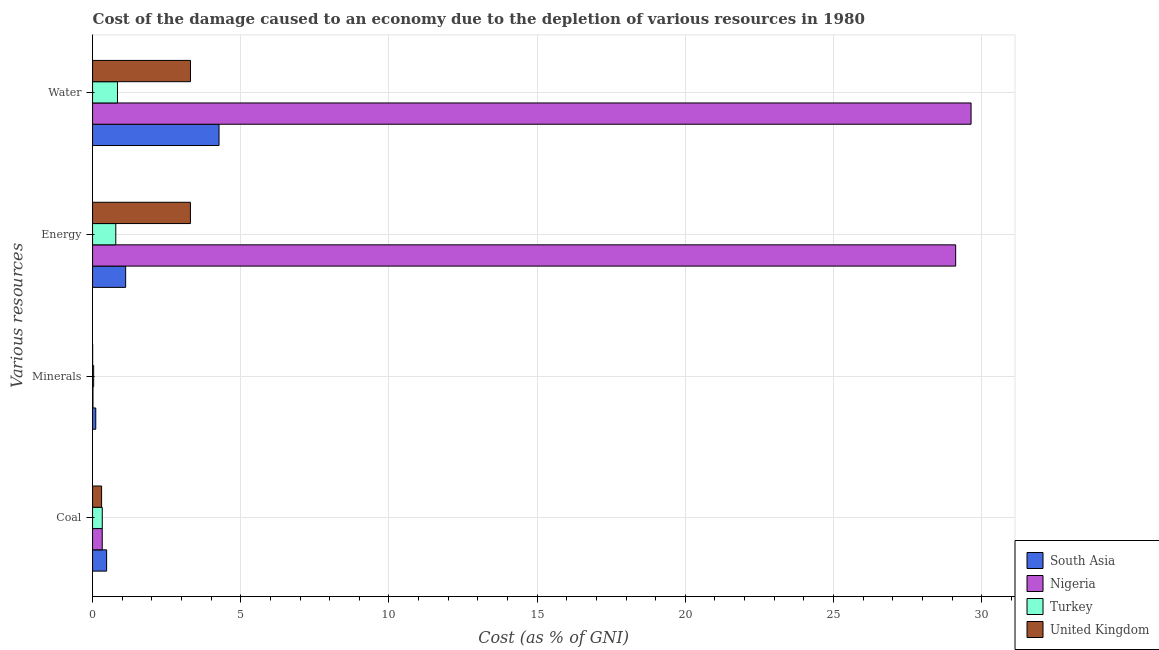How many different coloured bars are there?
Provide a succinct answer. 4. Are the number of bars per tick equal to the number of legend labels?
Make the answer very short. Yes. Are the number of bars on each tick of the Y-axis equal?
Ensure brevity in your answer.  Yes. How many bars are there on the 1st tick from the top?
Ensure brevity in your answer.  4. What is the label of the 3rd group of bars from the top?
Your answer should be very brief. Minerals. What is the cost of damage due to depletion of water in Nigeria?
Your answer should be compact. 29.64. Across all countries, what is the maximum cost of damage due to depletion of minerals?
Your answer should be very brief. 0.11. Across all countries, what is the minimum cost of damage due to depletion of energy?
Keep it short and to the point. 0.78. In which country was the cost of damage due to depletion of water minimum?
Your answer should be very brief. Turkey. What is the total cost of damage due to depletion of coal in the graph?
Provide a succinct answer. 1.43. What is the difference between the cost of damage due to depletion of water in Turkey and that in Nigeria?
Your response must be concise. -28.8. What is the difference between the cost of damage due to depletion of minerals in Turkey and the cost of damage due to depletion of water in United Kingdom?
Provide a succinct answer. -3.27. What is the average cost of damage due to depletion of water per country?
Your response must be concise. 9.51. What is the difference between the cost of damage due to depletion of coal and cost of damage due to depletion of minerals in United Kingdom?
Your answer should be compact. 0.3. What is the ratio of the cost of damage due to depletion of water in United Kingdom to that in Turkey?
Offer a terse response. 3.93. Is the difference between the cost of damage due to depletion of water in Turkey and Nigeria greater than the difference between the cost of damage due to depletion of coal in Turkey and Nigeria?
Give a very brief answer. No. What is the difference between the highest and the second highest cost of damage due to depletion of energy?
Your answer should be very brief. 25.82. What is the difference between the highest and the lowest cost of damage due to depletion of energy?
Provide a succinct answer. 28.34. In how many countries, is the cost of damage due to depletion of energy greater than the average cost of damage due to depletion of energy taken over all countries?
Your answer should be compact. 1. Is the sum of the cost of damage due to depletion of water in Turkey and United Kingdom greater than the maximum cost of damage due to depletion of minerals across all countries?
Your answer should be very brief. Yes. Is it the case that in every country, the sum of the cost of damage due to depletion of water and cost of damage due to depletion of minerals is greater than the sum of cost of damage due to depletion of coal and cost of damage due to depletion of energy?
Ensure brevity in your answer.  Yes. What does the 3rd bar from the bottom in Minerals represents?
Provide a short and direct response. Turkey. How many bars are there?
Your answer should be very brief. 16. What is the difference between two consecutive major ticks on the X-axis?
Make the answer very short. 5. Are the values on the major ticks of X-axis written in scientific E-notation?
Your answer should be very brief. No. Does the graph contain any zero values?
Offer a terse response. No. Does the graph contain grids?
Offer a terse response. Yes. How many legend labels are there?
Provide a short and direct response. 4. How are the legend labels stacked?
Make the answer very short. Vertical. What is the title of the graph?
Your response must be concise. Cost of the damage caused to an economy due to the depletion of various resources in 1980 . Does "United States" appear as one of the legend labels in the graph?
Make the answer very short. No. What is the label or title of the X-axis?
Provide a short and direct response. Cost (as % of GNI). What is the label or title of the Y-axis?
Offer a very short reply. Various resources. What is the Cost (as % of GNI) of South Asia in Coal?
Offer a very short reply. 0.47. What is the Cost (as % of GNI) in Nigeria in Coal?
Your response must be concise. 0.33. What is the Cost (as % of GNI) of Turkey in Coal?
Your response must be concise. 0.33. What is the Cost (as % of GNI) in United Kingdom in Coal?
Give a very brief answer. 0.3. What is the Cost (as % of GNI) of South Asia in Minerals?
Give a very brief answer. 0.11. What is the Cost (as % of GNI) in Nigeria in Minerals?
Your answer should be compact. 0.01. What is the Cost (as % of GNI) in Turkey in Minerals?
Ensure brevity in your answer.  0.04. What is the Cost (as % of GNI) in United Kingdom in Minerals?
Keep it short and to the point. 0. What is the Cost (as % of GNI) in South Asia in Energy?
Provide a short and direct response. 1.12. What is the Cost (as % of GNI) of Nigeria in Energy?
Offer a very short reply. 29.12. What is the Cost (as % of GNI) in Turkey in Energy?
Ensure brevity in your answer.  0.78. What is the Cost (as % of GNI) of United Kingdom in Energy?
Give a very brief answer. 3.3. What is the Cost (as % of GNI) of South Asia in Water?
Your response must be concise. 4.27. What is the Cost (as % of GNI) in Nigeria in Water?
Offer a very short reply. 29.64. What is the Cost (as % of GNI) of Turkey in Water?
Your answer should be very brief. 0.84. What is the Cost (as % of GNI) in United Kingdom in Water?
Offer a very short reply. 3.3. Across all Various resources, what is the maximum Cost (as % of GNI) in South Asia?
Offer a terse response. 4.27. Across all Various resources, what is the maximum Cost (as % of GNI) in Nigeria?
Provide a short and direct response. 29.64. Across all Various resources, what is the maximum Cost (as % of GNI) in Turkey?
Your response must be concise. 0.84. Across all Various resources, what is the maximum Cost (as % of GNI) of United Kingdom?
Offer a very short reply. 3.3. Across all Various resources, what is the minimum Cost (as % of GNI) of South Asia?
Your answer should be compact. 0.11. Across all Various resources, what is the minimum Cost (as % of GNI) of Nigeria?
Ensure brevity in your answer.  0.01. Across all Various resources, what is the minimum Cost (as % of GNI) of Turkey?
Provide a succinct answer. 0.04. Across all Various resources, what is the minimum Cost (as % of GNI) in United Kingdom?
Your answer should be compact. 0. What is the total Cost (as % of GNI) in South Asia in the graph?
Your response must be concise. 5.96. What is the total Cost (as % of GNI) of Nigeria in the graph?
Ensure brevity in your answer.  59.11. What is the total Cost (as % of GNI) of Turkey in the graph?
Ensure brevity in your answer.  1.99. What is the total Cost (as % of GNI) of United Kingdom in the graph?
Offer a terse response. 6.91. What is the difference between the Cost (as % of GNI) of South Asia in Coal and that in Minerals?
Provide a short and direct response. 0.37. What is the difference between the Cost (as % of GNI) of Nigeria in Coal and that in Minerals?
Offer a terse response. 0.31. What is the difference between the Cost (as % of GNI) in Turkey in Coal and that in Minerals?
Ensure brevity in your answer.  0.29. What is the difference between the Cost (as % of GNI) of United Kingdom in Coal and that in Minerals?
Provide a succinct answer. 0.3. What is the difference between the Cost (as % of GNI) in South Asia in Coal and that in Energy?
Make the answer very short. -0.64. What is the difference between the Cost (as % of GNI) in Nigeria in Coal and that in Energy?
Your answer should be very brief. -28.8. What is the difference between the Cost (as % of GNI) of Turkey in Coal and that in Energy?
Provide a succinct answer. -0.46. What is the difference between the Cost (as % of GNI) of United Kingdom in Coal and that in Energy?
Your answer should be compact. -3. What is the difference between the Cost (as % of GNI) in South Asia in Coal and that in Water?
Keep it short and to the point. -3.79. What is the difference between the Cost (as % of GNI) in Nigeria in Coal and that in Water?
Your answer should be compact. -29.32. What is the difference between the Cost (as % of GNI) in Turkey in Coal and that in Water?
Make the answer very short. -0.51. What is the difference between the Cost (as % of GNI) of United Kingdom in Coal and that in Water?
Your answer should be very brief. -3. What is the difference between the Cost (as % of GNI) in South Asia in Minerals and that in Energy?
Your response must be concise. -1.01. What is the difference between the Cost (as % of GNI) of Nigeria in Minerals and that in Energy?
Ensure brevity in your answer.  -29.11. What is the difference between the Cost (as % of GNI) in Turkey in Minerals and that in Energy?
Ensure brevity in your answer.  -0.75. What is the difference between the Cost (as % of GNI) of United Kingdom in Minerals and that in Energy?
Ensure brevity in your answer.  -3.3. What is the difference between the Cost (as % of GNI) in South Asia in Minerals and that in Water?
Offer a terse response. -4.16. What is the difference between the Cost (as % of GNI) of Nigeria in Minerals and that in Water?
Offer a very short reply. -29.63. What is the difference between the Cost (as % of GNI) in Turkey in Minerals and that in Water?
Ensure brevity in your answer.  -0.8. What is the difference between the Cost (as % of GNI) of United Kingdom in Minerals and that in Water?
Ensure brevity in your answer.  -3.3. What is the difference between the Cost (as % of GNI) of South Asia in Energy and that in Water?
Make the answer very short. -3.15. What is the difference between the Cost (as % of GNI) of Nigeria in Energy and that in Water?
Ensure brevity in your answer.  -0.52. What is the difference between the Cost (as % of GNI) of Turkey in Energy and that in Water?
Provide a short and direct response. -0.06. What is the difference between the Cost (as % of GNI) of United Kingdom in Energy and that in Water?
Offer a very short reply. -0. What is the difference between the Cost (as % of GNI) in South Asia in Coal and the Cost (as % of GNI) in Nigeria in Minerals?
Offer a very short reply. 0.46. What is the difference between the Cost (as % of GNI) of South Asia in Coal and the Cost (as % of GNI) of Turkey in Minerals?
Ensure brevity in your answer.  0.44. What is the difference between the Cost (as % of GNI) in South Asia in Coal and the Cost (as % of GNI) in United Kingdom in Minerals?
Give a very brief answer. 0.47. What is the difference between the Cost (as % of GNI) in Nigeria in Coal and the Cost (as % of GNI) in Turkey in Minerals?
Provide a succinct answer. 0.29. What is the difference between the Cost (as % of GNI) of Nigeria in Coal and the Cost (as % of GNI) of United Kingdom in Minerals?
Give a very brief answer. 0.32. What is the difference between the Cost (as % of GNI) of Turkey in Coal and the Cost (as % of GNI) of United Kingdom in Minerals?
Your answer should be compact. 0.32. What is the difference between the Cost (as % of GNI) in South Asia in Coal and the Cost (as % of GNI) in Nigeria in Energy?
Your response must be concise. -28.65. What is the difference between the Cost (as % of GNI) in South Asia in Coal and the Cost (as % of GNI) in Turkey in Energy?
Keep it short and to the point. -0.31. What is the difference between the Cost (as % of GNI) of South Asia in Coal and the Cost (as % of GNI) of United Kingdom in Energy?
Provide a succinct answer. -2.83. What is the difference between the Cost (as % of GNI) of Nigeria in Coal and the Cost (as % of GNI) of Turkey in Energy?
Offer a terse response. -0.46. What is the difference between the Cost (as % of GNI) of Nigeria in Coal and the Cost (as % of GNI) of United Kingdom in Energy?
Your response must be concise. -2.98. What is the difference between the Cost (as % of GNI) in Turkey in Coal and the Cost (as % of GNI) in United Kingdom in Energy?
Ensure brevity in your answer.  -2.97. What is the difference between the Cost (as % of GNI) of South Asia in Coal and the Cost (as % of GNI) of Nigeria in Water?
Your answer should be compact. -29.17. What is the difference between the Cost (as % of GNI) of South Asia in Coal and the Cost (as % of GNI) of Turkey in Water?
Provide a short and direct response. -0.37. What is the difference between the Cost (as % of GNI) in South Asia in Coal and the Cost (as % of GNI) in United Kingdom in Water?
Provide a short and direct response. -2.83. What is the difference between the Cost (as % of GNI) of Nigeria in Coal and the Cost (as % of GNI) of Turkey in Water?
Ensure brevity in your answer.  -0.52. What is the difference between the Cost (as % of GNI) of Nigeria in Coal and the Cost (as % of GNI) of United Kingdom in Water?
Make the answer very short. -2.98. What is the difference between the Cost (as % of GNI) in Turkey in Coal and the Cost (as % of GNI) in United Kingdom in Water?
Your answer should be compact. -2.98. What is the difference between the Cost (as % of GNI) of South Asia in Minerals and the Cost (as % of GNI) of Nigeria in Energy?
Offer a very short reply. -29.02. What is the difference between the Cost (as % of GNI) of South Asia in Minerals and the Cost (as % of GNI) of Turkey in Energy?
Offer a terse response. -0.68. What is the difference between the Cost (as % of GNI) in South Asia in Minerals and the Cost (as % of GNI) in United Kingdom in Energy?
Provide a succinct answer. -3.19. What is the difference between the Cost (as % of GNI) of Nigeria in Minerals and the Cost (as % of GNI) of Turkey in Energy?
Your answer should be compact. -0.77. What is the difference between the Cost (as % of GNI) of Nigeria in Minerals and the Cost (as % of GNI) of United Kingdom in Energy?
Make the answer very short. -3.29. What is the difference between the Cost (as % of GNI) in Turkey in Minerals and the Cost (as % of GNI) in United Kingdom in Energy?
Ensure brevity in your answer.  -3.27. What is the difference between the Cost (as % of GNI) of South Asia in Minerals and the Cost (as % of GNI) of Nigeria in Water?
Your answer should be very brief. -29.54. What is the difference between the Cost (as % of GNI) of South Asia in Minerals and the Cost (as % of GNI) of Turkey in Water?
Your answer should be very brief. -0.73. What is the difference between the Cost (as % of GNI) of South Asia in Minerals and the Cost (as % of GNI) of United Kingdom in Water?
Keep it short and to the point. -3.2. What is the difference between the Cost (as % of GNI) in Nigeria in Minerals and the Cost (as % of GNI) in Turkey in Water?
Your answer should be compact. -0.83. What is the difference between the Cost (as % of GNI) of Nigeria in Minerals and the Cost (as % of GNI) of United Kingdom in Water?
Your answer should be very brief. -3.29. What is the difference between the Cost (as % of GNI) of Turkey in Minerals and the Cost (as % of GNI) of United Kingdom in Water?
Your answer should be very brief. -3.27. What is the difference between the Cost (as % of GNI) in South Asia in Energy and the Cost (as % of GNI) in Nigeria in Water?
Your answer should be compact. -28.53. What is the difference between the Cost (as % of GNI) of South Asia in Energy and the Cost (as % of GNI) of Turkey in Water?
Make the answer very short. 0.28. What is the difference between the Cost (as % of GNI) in South Asia in Energy and the Cost (as % of GNI) in United Kingdom in Water?
Offer a very short reply. -2.19. What is the difference between the Cost (as % of GNI) in Nigeria in Energy and the Cost (as % of GNI) in Turkey in Water?
Keep it short and to the point. 28.28. What is the difference between the Cost (as % of GNI) in Nigeria in Energy and the Cost (as % of GNI) in United Kingdom in Water?
Ensure brevity in your answer.  25.82. What is the difference between the Cost (as % of GNI) of Turkey in Energy and the Cost (as % of GNI) of United Kingdom in Water?
Provide a succinct answer. -2.52. What is the average Cost (as % of GNI) of South Asia per Various resources?
Your answer should be compact. 1.49. What is the average Cost (as % of GNI) in Nigeria per Various resources?
Your answer should be very brief. 14.78. What is the average Cost (as % of GNI) of Turkey per Various resources?
Your answer should be very brief. 0.5. What is the average Cost (as % of GNI) in United Kingdom per Various resources?
Your answer should be compact. 1.73. What is the difference between the Cost (as % of GNI) in South Asia and Cost (as % of GNI) in Nigeria in Coal?
Provide a succinct answer. 0.15. What is the difference between the Cost (as % of GNI) in South Asia and Cost (as % of GNI) in Turkey in Coal?
Give a very brief answer. 0.15. What is the difference between the Cost (as % of GNI) in South Asia and Cost (as % of GNI) in United Kingdom in Coal?
Your answer should be very brief. 0.17. What is the difference between the Cost (as % of GNI) in Nigeria and Cost (as % of GNI) in Turkey in Coal?
Offer a terse response. -0. What is the difference between the Cost (as % of GNI) in Nigeria and Cost (as % of GNI) in United Kingdom in Coal?
Make the answer very short. 0.02. What is the difference between the Cost (as % of GNI) of Turkey and Cost (as % of GNI) of United Kingdom in Coal?
Keep it short and to the point. 0.02. What is the difference between the Cost (as % of GNI) in South Asia and Cost (as % of GNI) in Nigeria in Minerals?
Your answer should be compact. 0.09. What is the difference between the Cost (as % of GNI) of South Asia and Cost (as % of GNI) of Turkey in Minerals?
Your answer should be very brief. 0.07. What is the difference between the Cost (as % of GNI) in South Asia and Cost (as % of GNI) in United Kingdom in Minerals?
Your answer should be very brief. 0.11. What is the difference between the Cost (as % of GNI) in Nigeria and Cost (as % of GNI) in Turkey in Minerals?
Provide a succinct answer. -0.02. What is the difference between the Cost (as % of GNI) of Nigeria and Cost (as % of GNI) of United Kingdom in Minerals?
Make the answer very short. 0.01. What is the difference between the Cost (as % of GNI) of Turkey and Cost (as % of GNI) of United Kingdom in Minerals?
Your answer should be compact. 0.03. What is the difference between the Cost (as % of GNI) of South Asia and Cost (as % of GNI) of Nigeria in Energy?
Your answer should be compact. -28.01. What is the difference between the Cost (as % of GNI) in South Asia and Cost (as % of GNI) in Turkey in Energy?
Make the answer very short. 0.33. What is the difference between the Cost (as % of GNI) of South Asia and Cost (as % of GNI) of United Kingdom in Energy?
Make the answer very short. -2.19. What is the difference between the Cost (as % of GNI) in Nigeria and Cost (as % of GNI) in Turkey in Energy?
Make the answer very short. 28.34. What is the difference between the Cost (as % of GNI) of Nigeria and Cost (as % of GNI) of United Kingdom in Energy?
Your answer should be compact. 25.82. What is the difference between the Cost (as % of GNI) of Turkey and Cost (as % of GNI) of United Kingdom in Energy?
Provide a short and direct response. -2.52. What is the difference between the Cost (as % of GNI) of South Asia and Cost (as % of GNI) of Nigeria in Water?
Make the answer very short. -25.38. What is the difference between the Cost (as % of GNI) of South Asia and Cost (as % of GNI) of Turkey in Water?
Make the answer very short. 3.43. What is the difference between the Cost (as % of GNI) in South Asia and Cost (as % of GNI) in United Kingdom in Water?
Your response must be concise. 0.96. What is the difference between the Cost (as % of GNI) in Nigeria and Cost (as % of GNI) in Turkey in Water?
Your answer should be very brief. 28.8. What is the difference between the Cost (as % of GNI) of Nigeria and Cost (as % of GNI) of United Kingdom in Water?
Offer a terse response. 26.34. What is the difference between the Cost (as % of GNI) in Turkey and Cost (as % of GNI) in United Kingdom in Water?
Provide a short and direct response. -2.46. What is the ratio of the Cost (as % of GNI) of South Asia in Coal to that in Minerals?
Your answer should be compact. 4.4. What is the ratio of the Cost (as % of GNI) of Nigeria in Coal to that in Minerals?
Your response must be concise. 23.45. What is the ratio of the Cost (as % of GNI) of Turkey in Coal to that in Minerals?
Keep it short and to the point. 8.94. What is the ratio of the Cost (as % of GNI) of United Kingdom in Coal to that in Minerals?
Your response must be concise. 120.98. What is the ratio of the Cost (as % of GNI) in South Asia in Coal to that in Energy?
Give a very brief answer. 0.42. What is the ratio of the Cost (as % of GNI) of Nigeria in Coal to that in Energy?
Provide a short and direct response. 0.01. What is the ratio of the Cost (as % of GNI) of Turkey in Coal to that in Energy?
Give a very brief answer. 0.42. What is the ratio of the Cost (as % of GNI) in United Kingdom in Coal to that in Energy?
Your response must be concise. 0.09. What is the ratio of the Cost (as % of GNI) of South Asia in Coal to that in Water?
Your answer should be very brief. 0.11. What is the ratio of the Cost (as % of GNI) in Nigeria in Coal to that in Water?
Make the answer very short. 0.01. What is the ratio of the Cost (as % of GNI) in Turkey in Coal to that in Water?
Provide a succinct answer. 0.39. What is the ratio of the Cost (as % of GNI) in United Kingdom in Coal to that in Water?
Your answer should be very brief. 0.09. What is the ratio of the Cost (as % of GNI) in South Asia in Minerals to that in Energy?
Keep it short and to the point. 0.1. What is the ratio of the Cost (as % of GNI) of Nigeria in Minerals to that in Energy?
Make the answer very short. 0. What is the ratio of the Cost (as % of GNI) in Turkey in Minerals to that in Energy?
Give a very brief answer. 0.05. What is the ratio of the Cost (as % of GNI) in United Kingdom in Minerals to that in Energy?
Offer a terse response. 0. What is the ratio of the Cost (as % of GNI) of South Asia in Minerals to that in Water?
Keep it short and to the point. 0.03. What is the ratio of the Cost (as % of GNI) in Nigeria in Minerals to that in Water?
Make the answer very short. 0. What is the ratio of the Cost (as % of GNI) of Turkey in Minerals to that in Water?
Keep it short and to the point. 0.04. What is the ratio of the Cost (as % of GNI) of United Kingdom in Minerals to that in Water?
Make the answer very short. 0. What is the ratio of the Cost (as % of GNI) in South Asia in Energy to that in Water?
Give a very brief answer. 0.26. What is the ratio of the Cost (as % of GNI) of Nigeria in Energy to that in Water?
Your answer should be compact. 0.98. What is the ratio of the Cost (as % of GNI) of Turkey in Energy to that in Water?
Your response must be concise. 0.93. What is the ratio of the Cost (as % of GNI) in United Kingdom in Energy to that in Water?
Offer a very short reply. 1. What is the difference between the highest and the second highest Cost (as % of GNI) in South Asia?
Make the answer very short. 3.15. What is the difference between the highest and the second highest Cost (as % of GNI) in Nigeria?
Give a very brief answer. 0.52. What is the difference between the highest and the second highest Cost (as % of GNI) in Turkey?
Provide a short and direct response. 0.06. What is the difference between the highest and the second highest Cost (as % of GNI) in United Kingdom?
Offer a very short reply. 0. What is the difference between the highest and the lowest Cost (as % of GNI) in South Asia?
Offer a terse response. 4.16. What is the difference between the highest and the lowest Cost (as % of GNI) of Nigeria?
Offer a terse response. 29.63. What is the difference between the highest and the lowest Cost (as % of GNI) of Turkey?
Provide a succinct answer. 0.8. What is the difference between the highest and the lowest Cost (as % of GNI) in United Kingdom?
Ensure brevity in your answer.  3.3. 